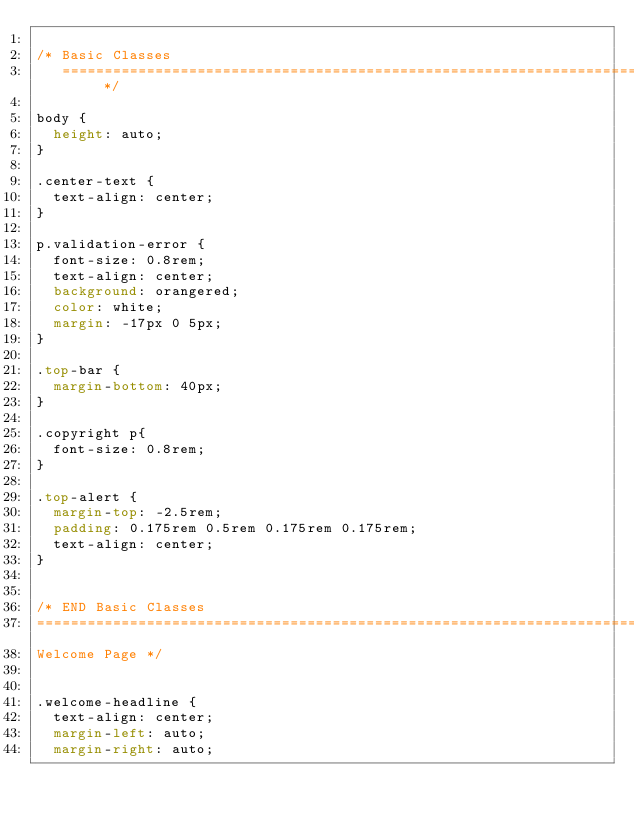Convert code to text. <code><loc_0><loc_0><loc_500><loc_500><_CSS_>
/* Basic Classes
   ========================================================================== */

body {
	height: auto;
}

.center-text {
  text-align: center;
}

p.validation-error {
  font-size: 0.8rem;
  text-align: center;
  background: orangered;
  color: white;
  margin: -17px 0 5px;
}

.top-bar {
  margin-bottom: 40px;
}

.copyright p{
  font-size: 0.8rem;
}

.top-alert {
  margin-top: -2.5rem;
  padding: 0.175rem 0.5rem 0.175rem 0.175rem;
  text-align: center;
}


/* END Basic Classes
========================================================================== 
Welcome Page */


.welcome-headline {
  text-align: center;
  margin-left: auto;
  margin-right: auto;</code> 